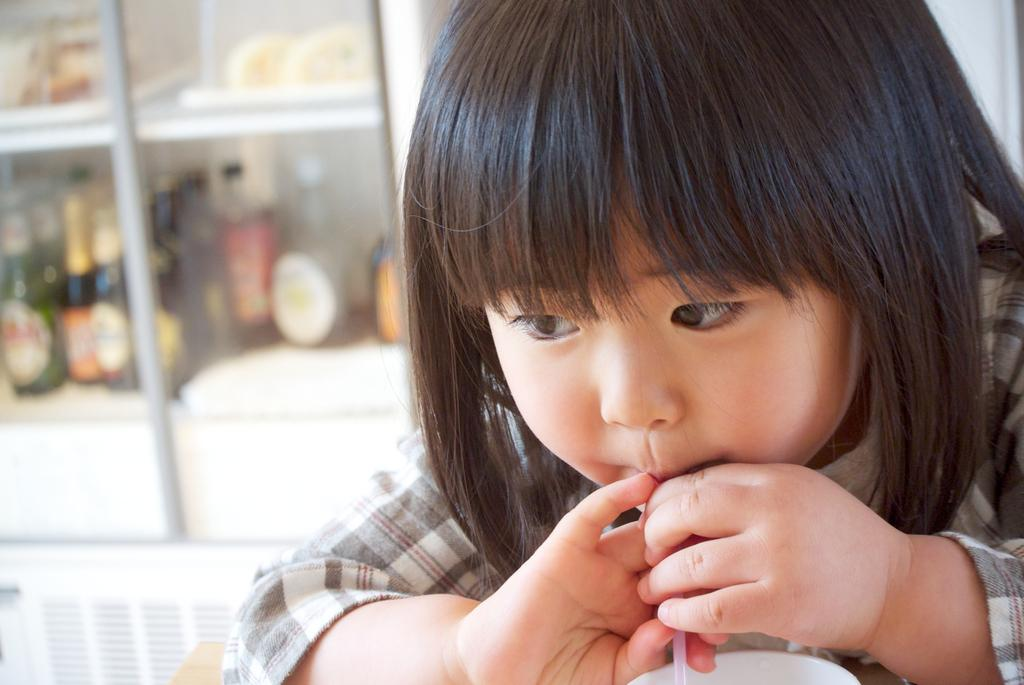What is the main subject of the image? There is a child in the image. What is the child holding in the image? The child is holding a straw. What can be seen in the background of the image? There is a cupboard in the background of the image, and there are bottles on the cupboard. How would you describe the background of the image? The background of the image is blurry. What type of trucks can be seen on the floor in the image? There are no trucks present in the image, and the floor is not visible in the provided facts. 